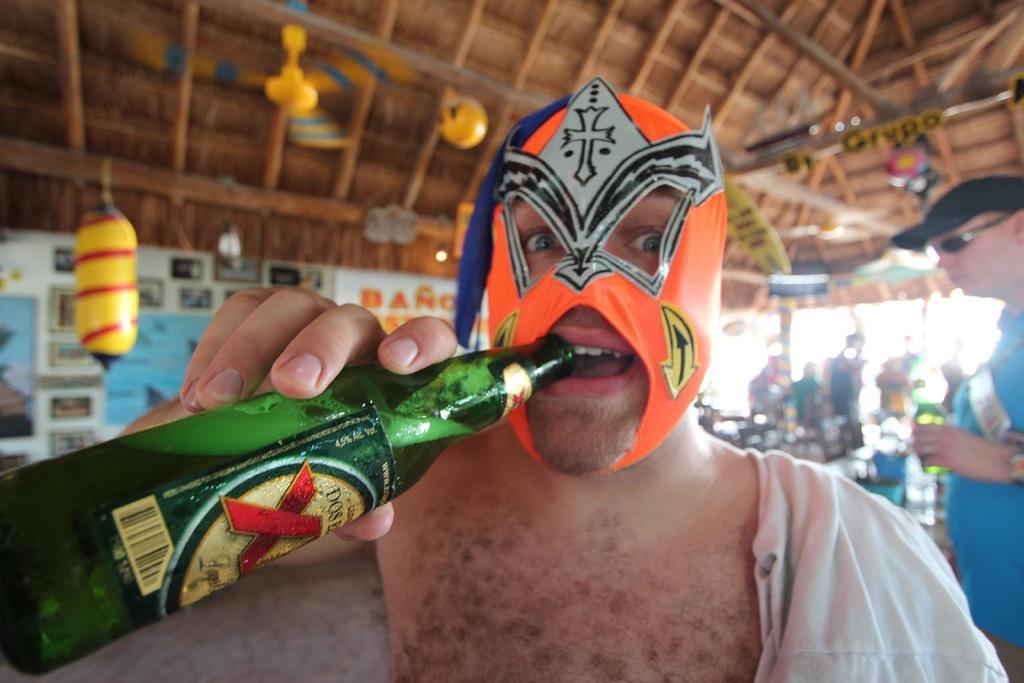Could you give a brief overview of what you see in this image? In this picture a guy who is wearing a face mask is drinking a liquid inside a green glass bottle. In the background we observe many people and the roof is designed beautifully with hangings and colored fans. 